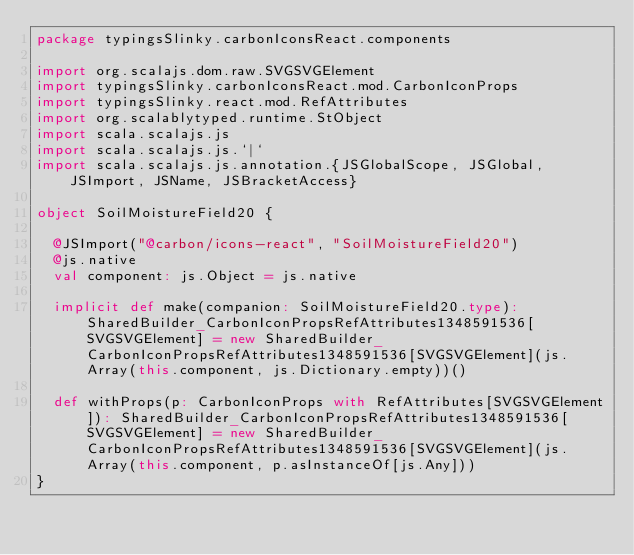<code> <loc_0><loc_0><loc_500><loc_500><_Scala_>package typingsSlinky.carbonIconsReact.components

import org.scalajs.dom.raw.SVGSVGElement
import typingsSlinky.carbonIconsReact.mod.CarbonIconProps
import typingsSlinky.react.mod.RefAttributes
import org.scalablytyped.runtime.StObject
import scala.scalajs.js
import scala.scalajs.js.`|`
import scala.scalajs.js.annotation.{JSGlobalScope, JSGlobal, JSImport, JSName, JSBracketAccess}

object SoilMoistureField20 {
  
  @JSImport("@carbon/icons-react", "SoilMoistureField20")
  @js.native
  val component: js.Object = js.native
  
  implicit def make(companion: SoilMoistureField20.type): SharedBuilder_CarbonIconPropsRefAttributes1348591536[SVGSVGElement] = new SharedBuilder_CarbonIconPropsRefAttributes1348591536[SVGSVGElement](js.Array(this.component, js.Dictionary.empty))()
  
  def withProps(p: CarbonIconProps with RefAttributes[SVGSVGElement]): SharedBuilder_CarbonIconPropsRefAttributes1348591536[SVGSVGElement] = new SharedBuilder_CarbonIconPropsRefAttributes1348591536[SVGSVGElement](js.Array(this.component, p.asInstanceOf[js.Any]))
}
</code> 